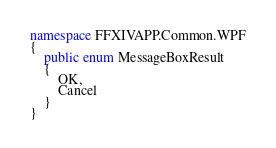<code> <loc_0><loc_0><loc_500><loc_500><_C#_>namespace FFXIVAPP.Common.WPF
{
    public enum MessageBoxResult
    {
        OK,
        Cancel
    }
}</code> 